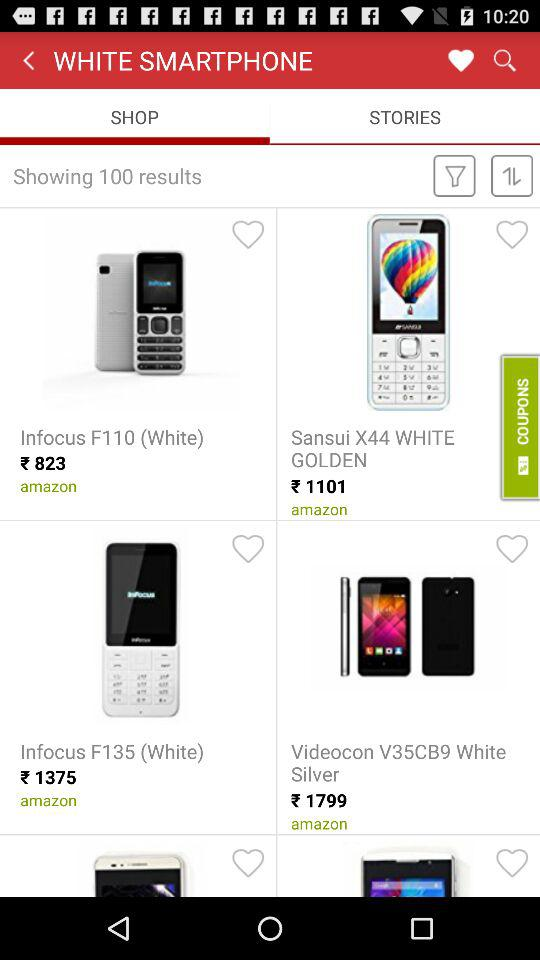What is the price of "Sansui X44 WHITE GOLDEN"? The price of "Sansui X44 WHITE GOLDEN" is ₹1101. 